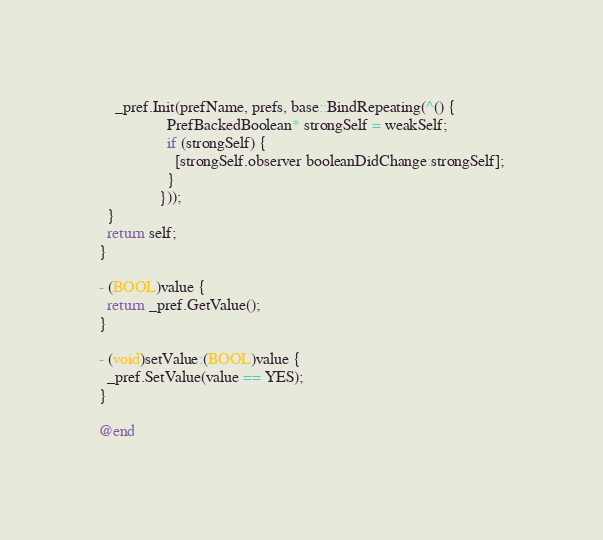<code> <loc_0><loc_0><loc_500><loc_500><_ObjectiveC_>    _pref.Init(prefName, prefs, base::BindRepeating(^() {
                 PrefBackedBoolean* strongSelf = weakSelf;
                 if (strongSelf) {
                   [strongSelf.observer booleanDidChange:strongSelf];
                 }
               }));
  }
  return self;
}

- (BOOL)value {
  return _pref.GetValue();
}

- (void)setValue:(BOOL)value {
  _pref.SetValue(value == YES);
}

@end
</code> 